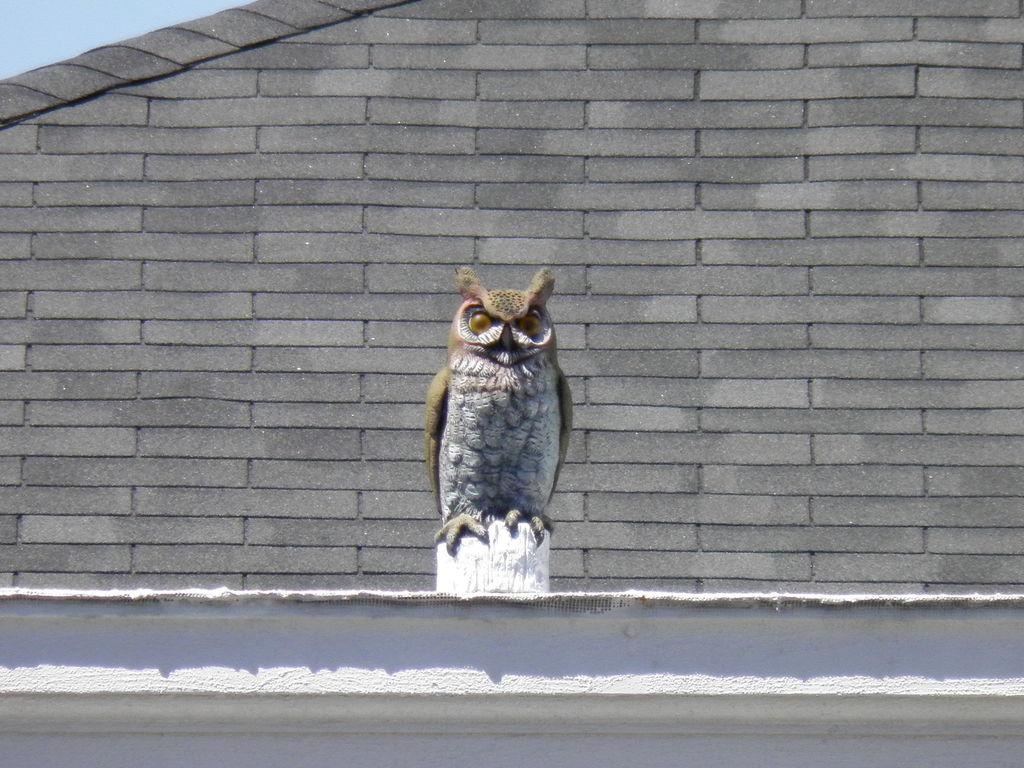What type of animal is depicted in the sculpture in the image? There is a sculpture of an owl in the image. Where is the sculpture located in relation to the image? The sculpture is in the front of the image. What can be seen in the background of the image? There is a wall visible in the background of the image. What type of yarn is being used by the owl to write a message on the wall in the image? There is no yarn or writing present in the image; it only features a sculpture of an owl and a wall in the background. 